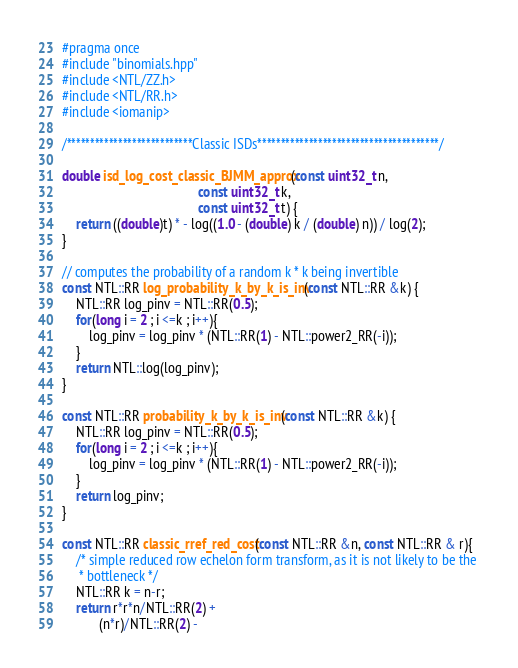<code> <loc_0><loc_0><loc_500><loc_500><_C++_>#pragma once 
#include "binomials.hpp"
#include <NTL/ZZ.h>
#include <NTL/RR.h>
#include <iomanip>

/***************************Classic ISDs***************************************/

double isd_log_cost_classic_BJMM_approx(const uint32_t n, 
                                        const uint32_t k,
                                        const uint32_t t) {
    return ((double)t) * - log((1.0 - (double) k / (double) n)) / log(2);
}

// computes the probability of a random k * k being invertible
const NTL::RR log_probability_k_by_k_is_inv(const NTL::RR &k) {
    NTL::RR log_pinv = NTL::RR(0.5);
    for(long i = 2 ; i <=k ; i++){
        log_pinv = log_pinv * (NTL::RR(1) - NTL::power2_RR(-i));
    }
    return NTL::log(log_pinv);
}

const NTL::RR probability_k_by_k_is_inv(const NTL::RR &k) {
    NTL::RR log_pinv = NTL::RR(0.5);
    for(long i = 2 ; i <=k ; i++){
        log_pinv = log_pinv * (NTL::RR(1) - NTL::power2_RR(-i));
    }
    return log_pinv;
}

const NTL::RR classic_rref_red_cost(const NTL::RR &n, const NTL::RR & r){
    /* simple reduced row echelon form transform, as it is not likely to be the 
     * bottleneck */
    NTL::RR k = n-r;
    return r*r*n/NTL::RR(2) + 
           (n*r)/NTL::RR(2) - </code> 